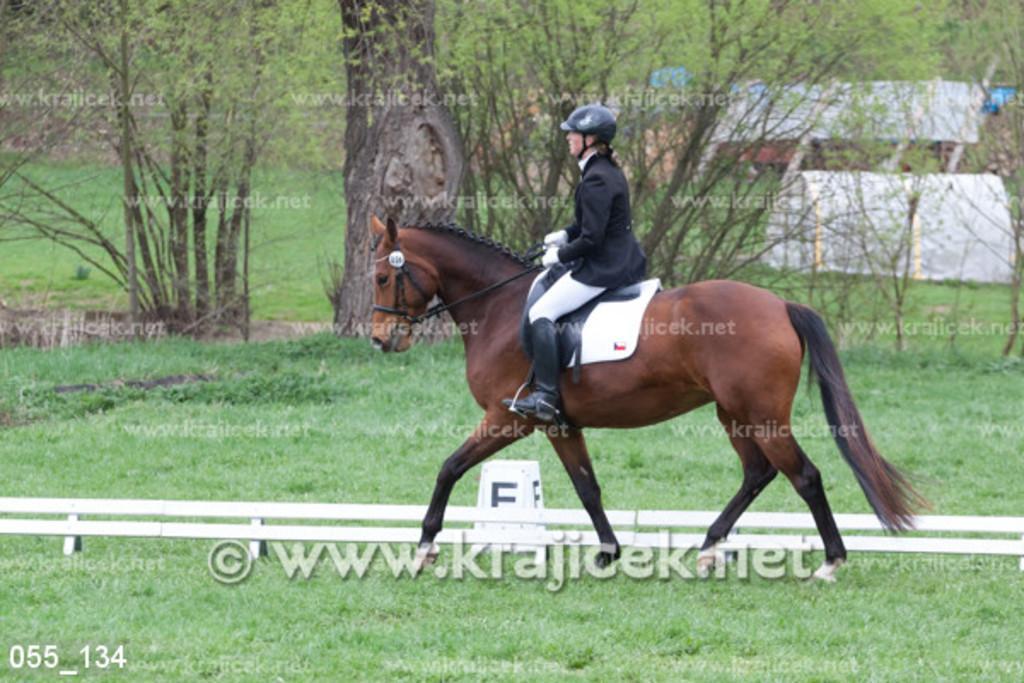In one or two sentences, can you explain what this image depicts? In this image we can see a person riding the horse. We can also see the barrier, watermark, trees and also the grass. In the bottom left corner we can see the numbers. 